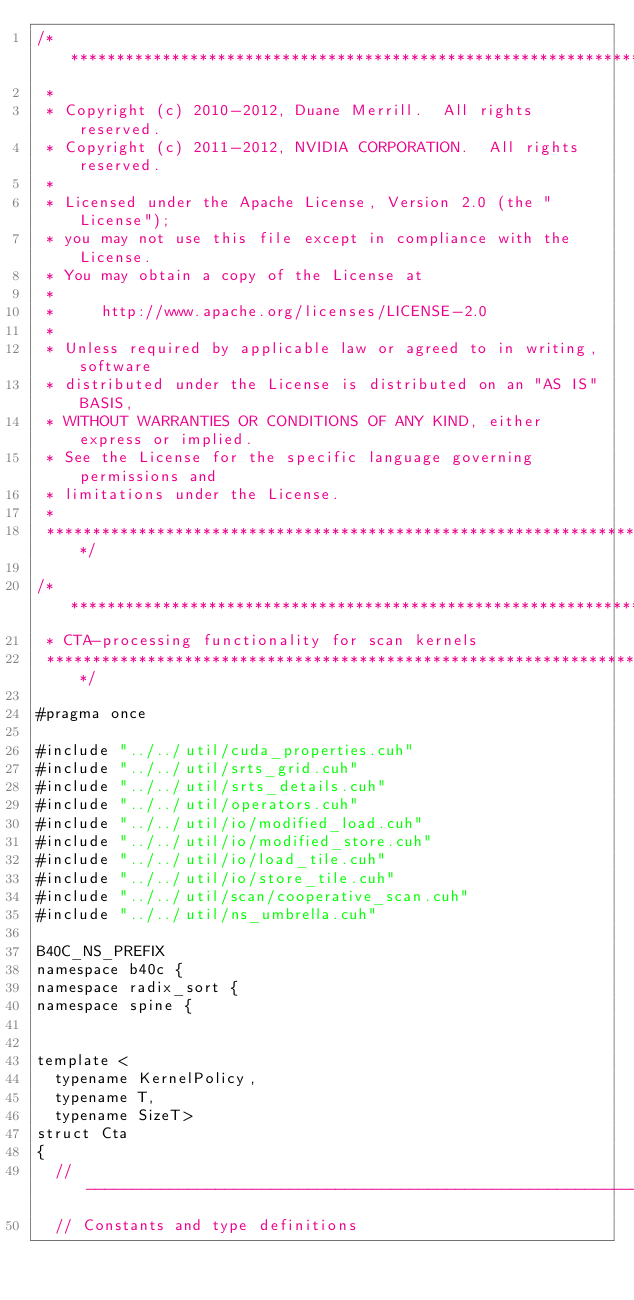<code> <loc_0><loc_0><loc_500><loc_500><_Cuda_>/******************************************************************************
 * 
 * Copyright (c) 2010-2012, Duane Merrill.  All rights reserved.
 * Copyright (c) 2011-2012, NVIDIA CORPORATION.  All rights reserved.
 * 
 * Licensed under the Apache License, Version 2.0 (the "License");
 * you may not use this file except in compliance with the License.
 * You may obtain a copy of the License at
 * 
 *     http://www.apache.org/licenses/LICENSE-2.0
 *
 * Unless required by applicable law or agreed to in writing, software
 * distributed under the License is distributed on an "AS IS" BASIS,
 * WITHOUT WARRANTIES OR CONDITIONS OF ANY KIND, either express or implied.
 * See the License for the specific language governing permissions and
 * limitations under the License. 
 * 
 ******************************************************************************/

/******************************************************************************
 * CTA-processing functionality for scan kernels
 ******************************************************************************/

#pragma once

#include "../../util/cuda_properties.cuh"
#include "../../util/srts_grid.cuh"
#include "../../util/srts_details.cuh"
#include "../../util/operators.cuh"
#include "../../util/io/modified_load.cuh"
#include "../../util/io/modified_store.cuh"
#include "../../util/io/load_tile.cuh"
#include "../../util/io/store_tile.cuh"
#include "../../util/scan/cooperative_scan.cuh"
#include "../../util/ns_umbrella.cuh"

B40C_NS_PREFIX
namespace b40c {
namespace radix_sort {
namespace spine {


template <
	typename KernelPolicy,
	typename T,
	typename SizeT>
struct Cta
{
	//---------------------------------------------------------------------
	// Constants and type definitions</code> 